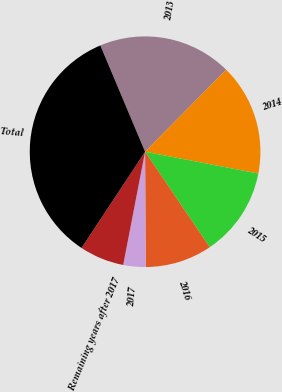Convert chart. <chart><loc_0><loc_0><loc_500><loc_500><pie_chart><fcel>2013<fcel>2014<fcel>2015<fcel>2016<fcel>2017<fcel>Remaining years after 2017<fcel>Total<nl><fcel>18.75%<fcel>15.62%<fcel>12.5%<fcel>9.38%<fcel>3.13%<fcel>6.25%<fcel>34.37%<nl></chart> 